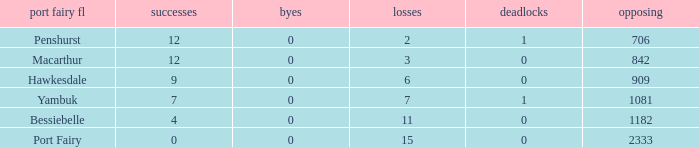How many wins for Port Fairy and against more than 2333? None. 